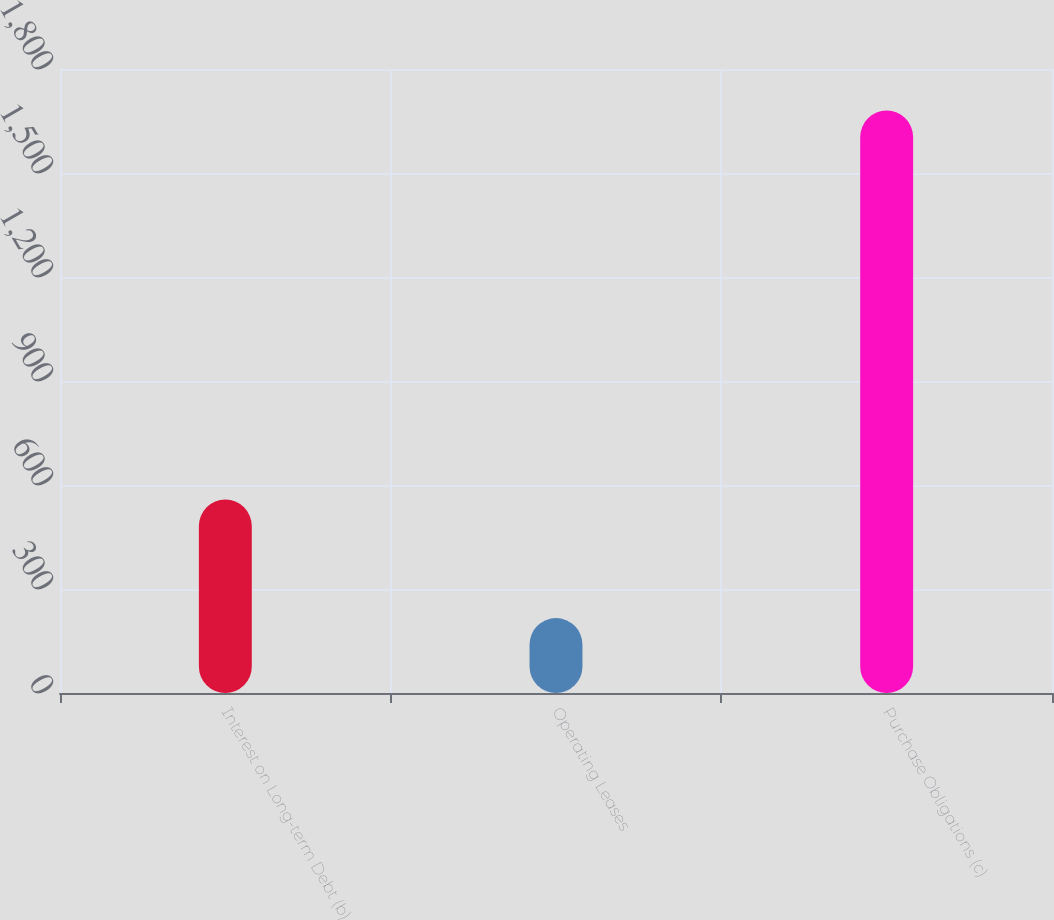<chart> <loc_0><loc_0><loc_500><loc_500><bar_chart><fcel>Interest on Long-term Debt (b)<fcel>Operating Leases<fcel>Purchase Obligations (c)<nl><fcel>558<fcel>216<fcel>1680<nl></chart> 